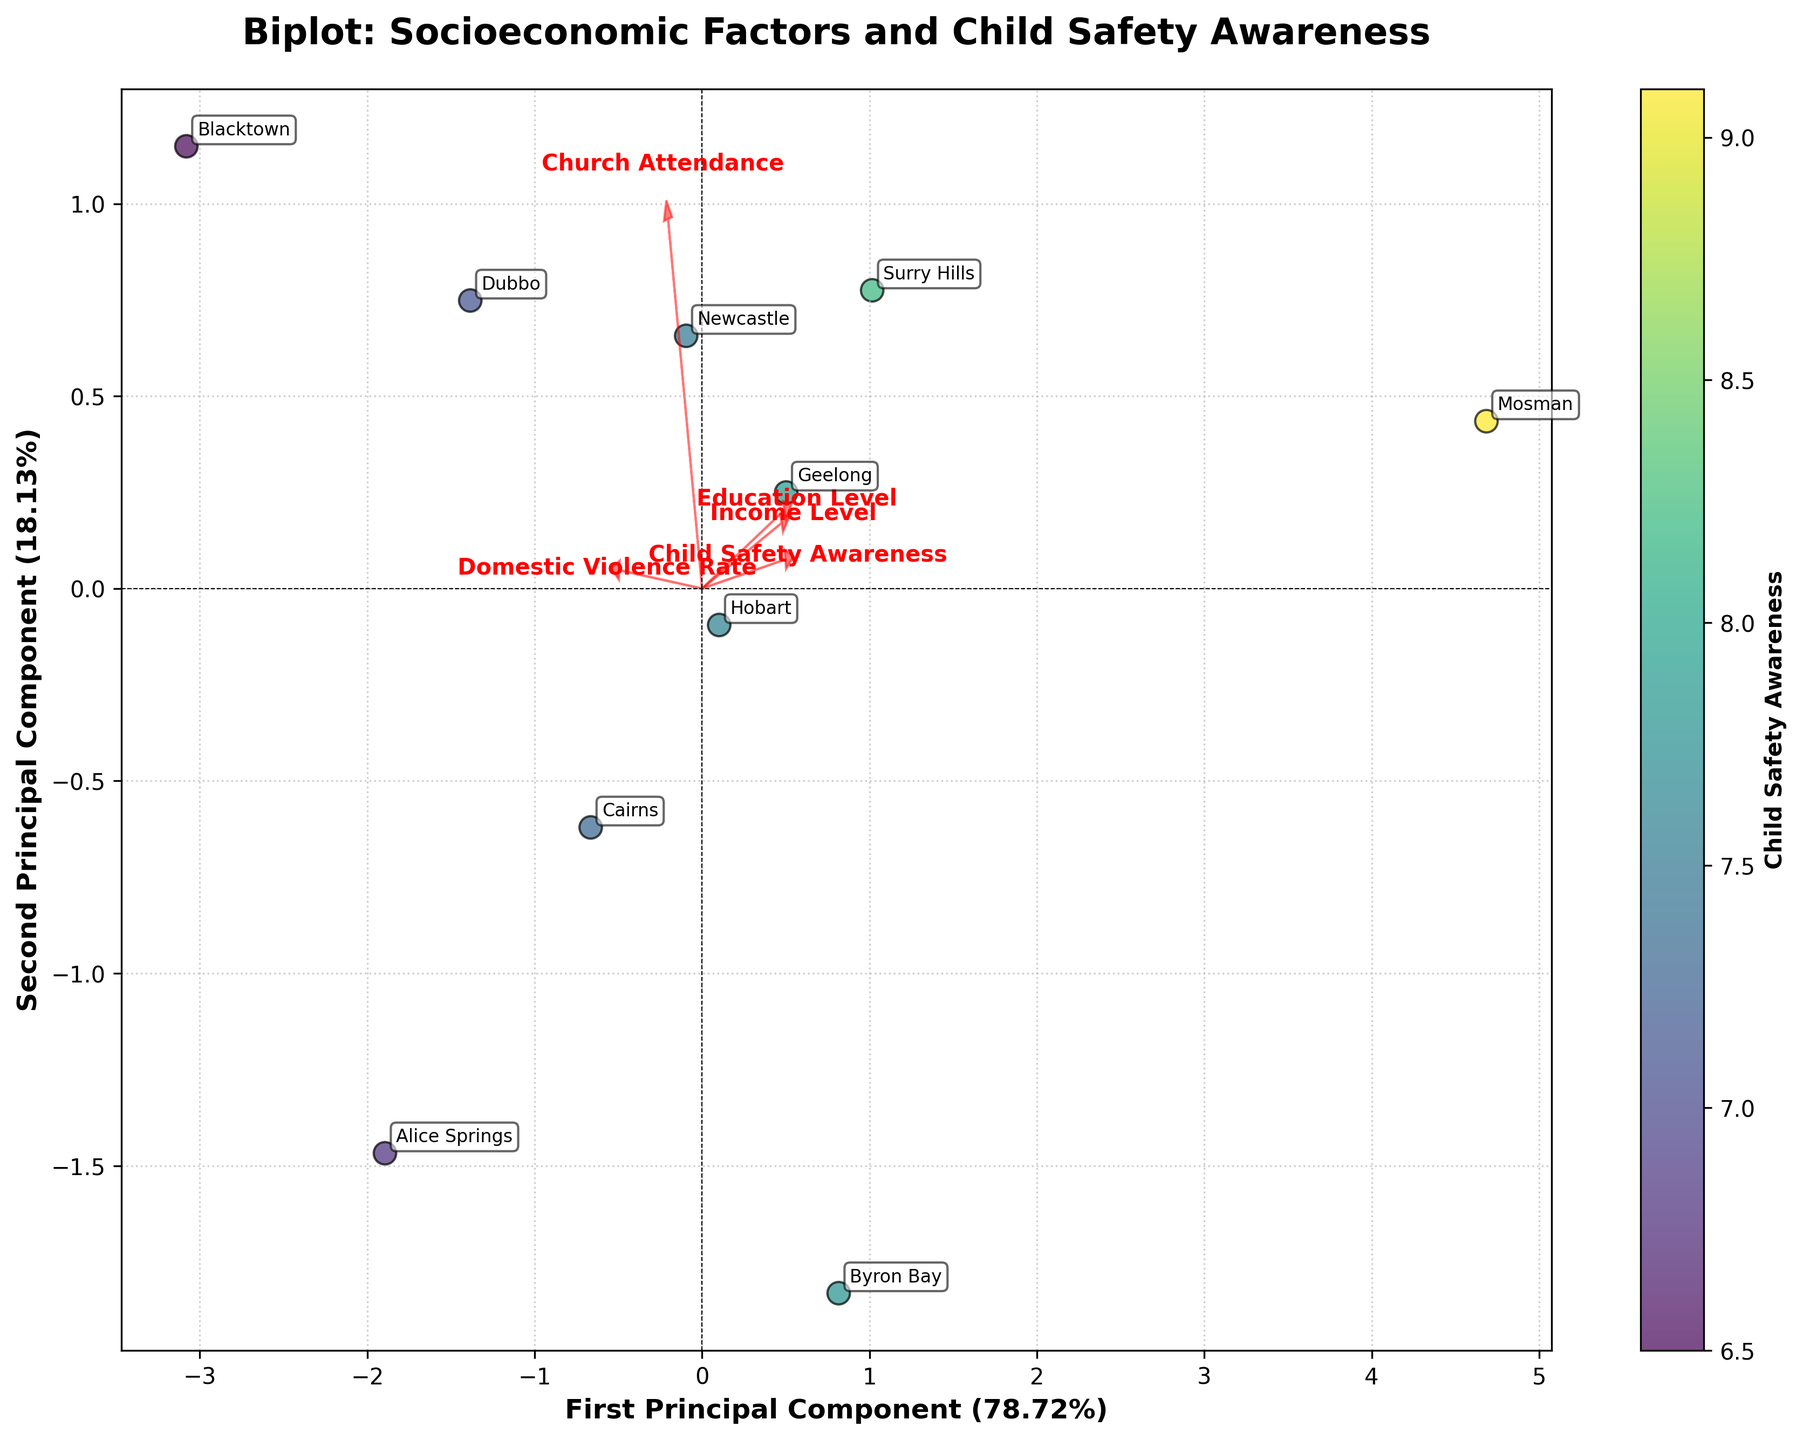How many communities are represented in the biplot? The communities are labeled on the plot. By counting the labels, we can determine the total number of communities.
Answer: 10 What do the colors in the scatter plot represent? Observing the color bar next to the plot, it indicates that colors represent the "Child Safety Awareness" levels.
Answer: Child Safety Awareness Which community has the highest Child Safety Awareness? By examining the color intensity and comparing with the communities' labels, Mosman has the highest color intensity, indicating the highest Child Safety Awareness score.
Answer: Mosman Which socioeconomic factor has the strongest correlation with the first principal component? By looking at the lengths and directions of the arrows in the plot, "Income Level" has the longest arrow in the direction of the first principal component, indicating the strongest correlation.
Answer: Income Level How are Domestic Violence Rate and Child Safety Awareness related in the communities? Analyzing the arrows' directions, Domestic Violence Rate and Child Safety Awareness arrows point in approximately opposite directions, indicating a negative correlation.
Answer: Negatively correlated Which community has the lowest score on the first principal component? By observing the plot's horizontal axis (first principal component) and finding the point farthest to the left, Blacktown has the lowest score on the first principal component.
Answer: Blacktown What is the general relationship between Education Level and Church Attendance according to the biplot? By analyzing the arrows for Education Level and Church Attendance, they are not pointing in the same direction, showing no strong correlation between these two variables.
Answer: No strong correlation Which two communities have the closest scores on the second principal component? By comparing the positions of points along the vertical axis (second principal component), Geelong and Cairns are closest to each other.
Answer: Geelong and Cairns Is the Child Safety Awareness higher in communities with higher Income Levels? By analyzing both Income Level and Child Safety Awareness arrows and their community positions, communities with higher income levels, like Mosman, tend to have higher Child Safety Awareness.
Answer: Yes What is the direction of the vector for Education Level? By looking at the plot, the vector for Education Level points towards the upper right direction from the origin.
Answer: Upper right 